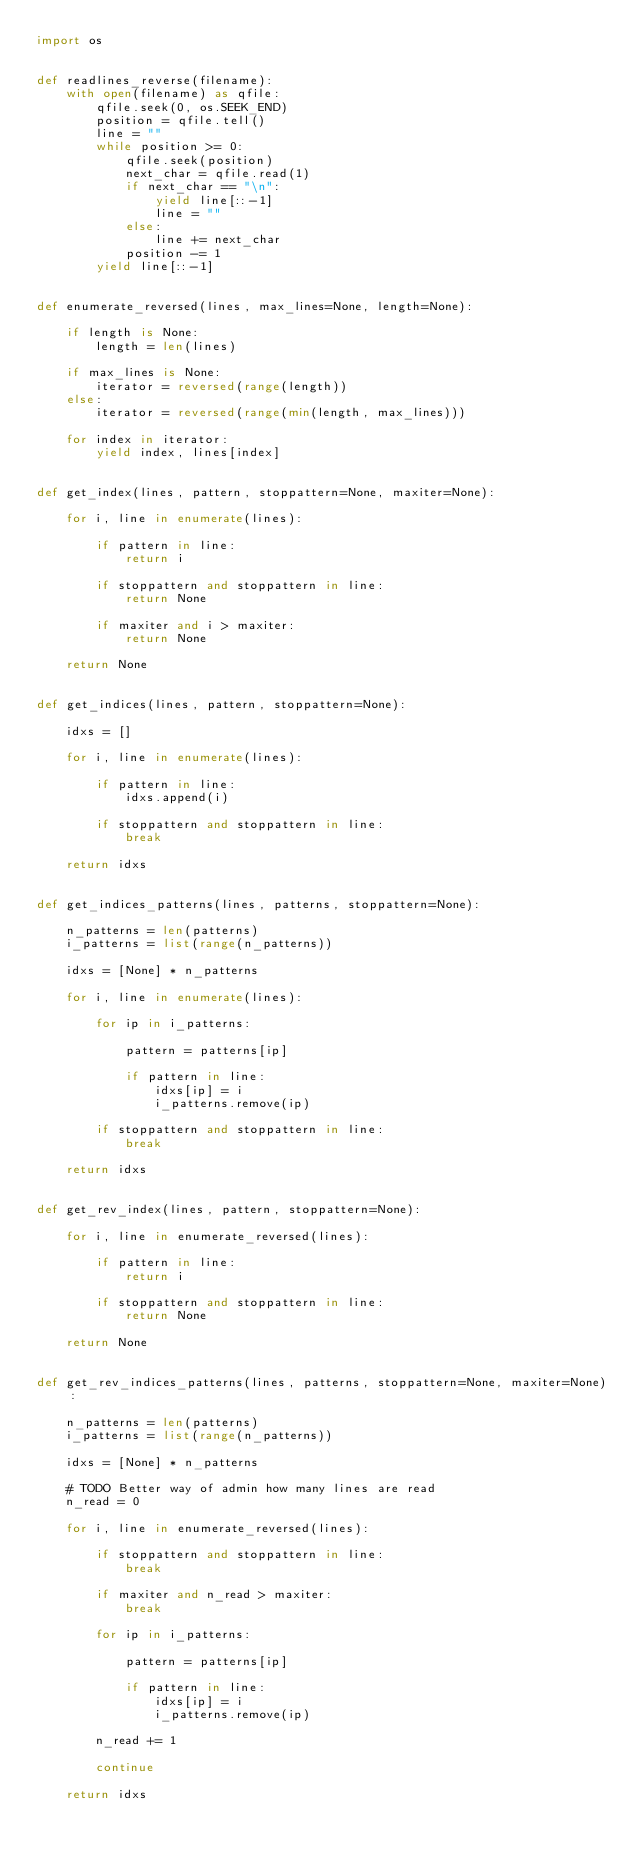<code> <loc_0><loc_0><loc_500><loc_500><_Python_>import os


def readlines_reverse(filename):
    with open(filename) as qfile:
        qfile.seek(0, os.SEEK_END)
        position = qfile.tell()
        line = ""
        while position >= 0:
            qfile.seek(position)
            next_char = qfile.read(1)
            if next_char == "\n":
                yield line[::-1]
                line = ""
            else:
                line += next_char
            position -= 1
        yield line[::-1]


def enumerate_reversed(lines, max_lines=None, length=None):

    if length is None:
        length = len(lines)

    if max_lines is None:
        iterator = reversed(range(length))
    else:
        iterator = reversed(range(min(length, max_lines)))

    for index in iterator:
        yield index, lines[index]


def get_index(lines, pattern, stoppattern=None, maxiter=None):

    for i, line in enumerate(lines):

        if pattern in line:
            return i

        if stoppattern and stoppattern in line:
            return None

        if maxiter and i > maxiter:
            return None

    return None


def get_indices(lines, pattern, stoppattern=None):

    idxs = []

    for i, line in enumerate(lines):

        if pattern in line:
            idxs.append(i)

        if stoppattern and stoppattern in line:
            break

    return idxs


def get_indices_patterns(lines, patterns, stoppattern=None):

    n_patterns = len(patterns)
    i_patterns = list(range(n_patterns))

    idxs = [None] * n_patterns

    for i, line in enumerate(lines):

        for ip in i_patterns:

            pattern = patterns[ip]

            if pattern in line:
                idxs[ip] = i
                i_patterns.remove(ip)

        if stoppattern and stoppattern in line:
            break

    return idxs


def get_rev_index(lines, pattern, stoppattern=None):

    for i, line in enumerate_reversed(lines):

        if pattern in line:
            return i

        if stoppattern and stoppattern in line:
            return None

    return None


def get_rev_indices_patterns(lines, patterns, stoppattern=None, maxiter=None):

    n_patterns = len(patterns)
    i_patterns = list(range(n_patterns))

    idxs = [None] * n_patterns

    # TODO Better way of admin how many lines are read
    n_read = 0

    for i, line in enumerate_reversed(lines):

        if stoppattern and stoppattern in line:
            break

        if maxiter and n_read > maxiter:
            break

        for ip in i_patterns:

            pattern = patterns[ip]

            if pattern in line:
                idxs[ip] = i
                i_patterns.remove(ip)

        n_read += 1

        continue

    return idxs
</code> 